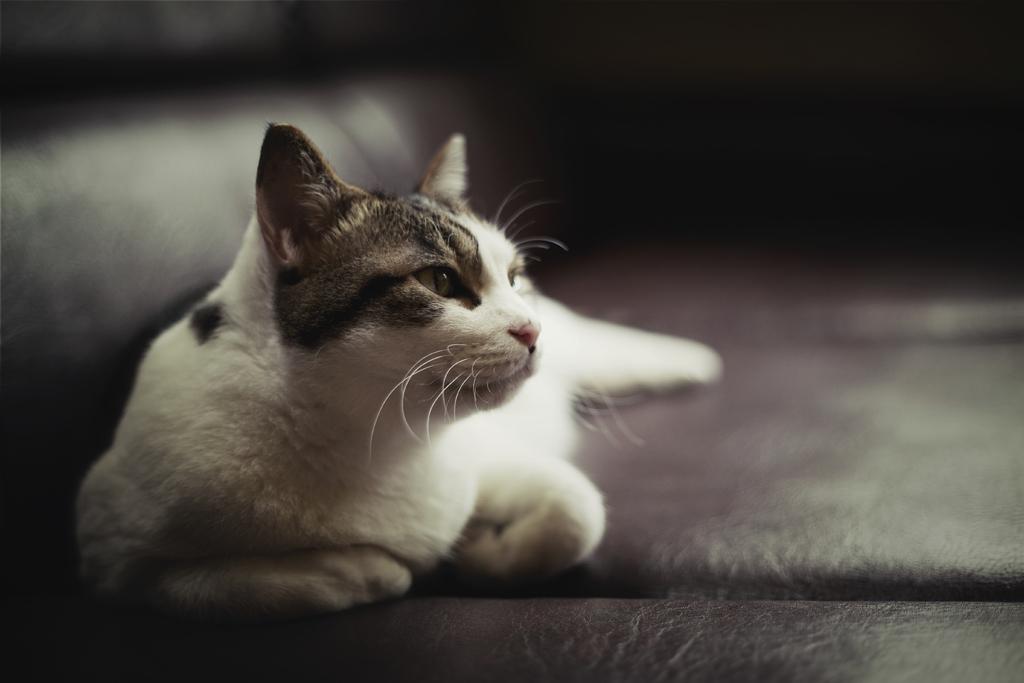How would you summarize this image in a sentence or two? In this image I can see a cat sitting on the floor and the cat is in white and brown color, and I can see blurred background. 